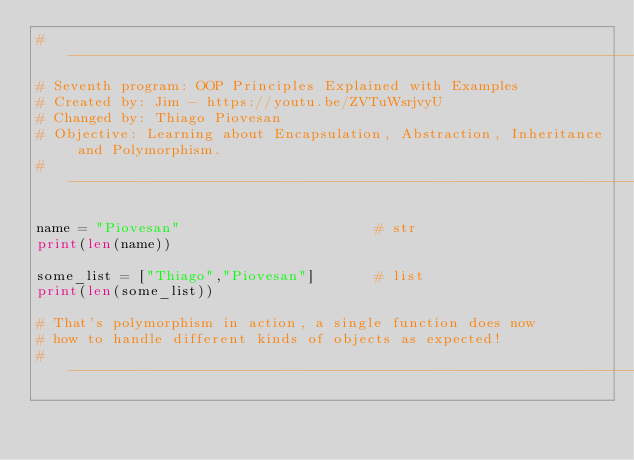Convert code to text. <code><loc_0><loc_0><loc_500><loc_500><_Python_>#--------------------------------------------------------------------#
# Seventh program: OOP Principles Explained with Examples
# Created by: Jim - https://youtu.be/ZVTuWsrjvyU
# Changed by: Thiago Piovesan
# Objective: Learning about Encapsulation, Abstraction, Inheritance and Polymorphism.
#--------------------------------------------------------------------#

name = "Piovesan"                       # str
print(len(name))

some_list = ["Thiago","Piovesan"]       # list
print(len(some_list))

# That's polymorphism in action, a single function does now
# how to handle different kinds of objects as expected!
#--------------------------------------------------------------------#
</code> 